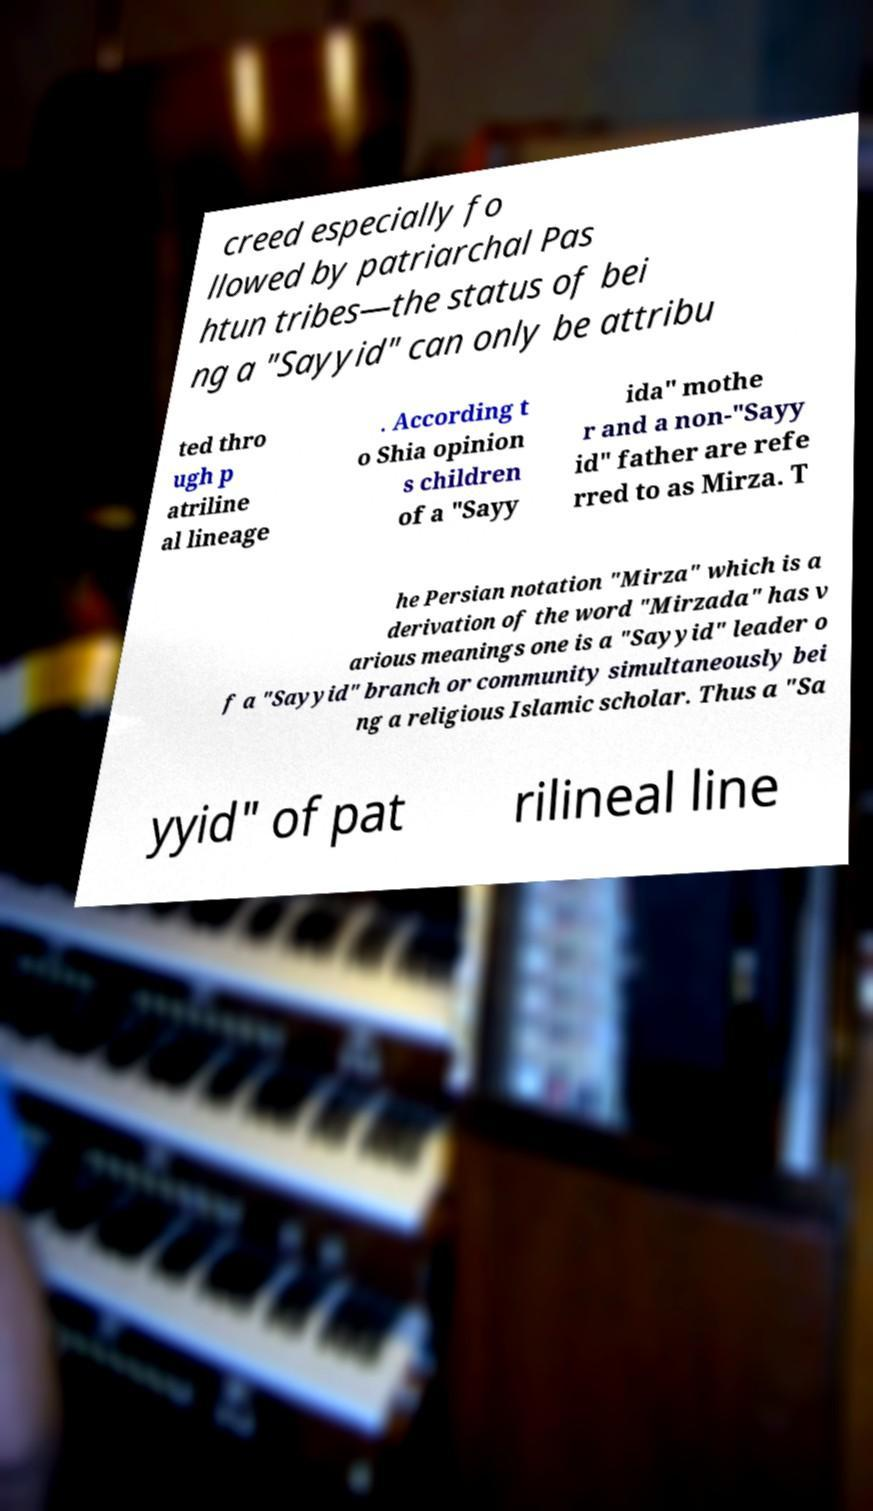What messages or text are displayed in this image? I need them in a readable, typed format. creed especially fo llowed by patriarchal Pas htun tribes—the status of bei ng a "Sayyid" can only be attribu ted thro ugh p atriline al lineage . According t o Shia opinion s children of a "Sayy ida" mothe r and a non-"Sayy id" father are refe rred to as Mirza. T he Persian notation "Mirza" which is a derivation of the word "Mirzada" has v arious meanings one is a "Sayyid" leader o f a "Sayyid" branch or community simultaneously bei ng a religious Islamic scholar. Thus a "Sa yyid" of pat rilineal line 